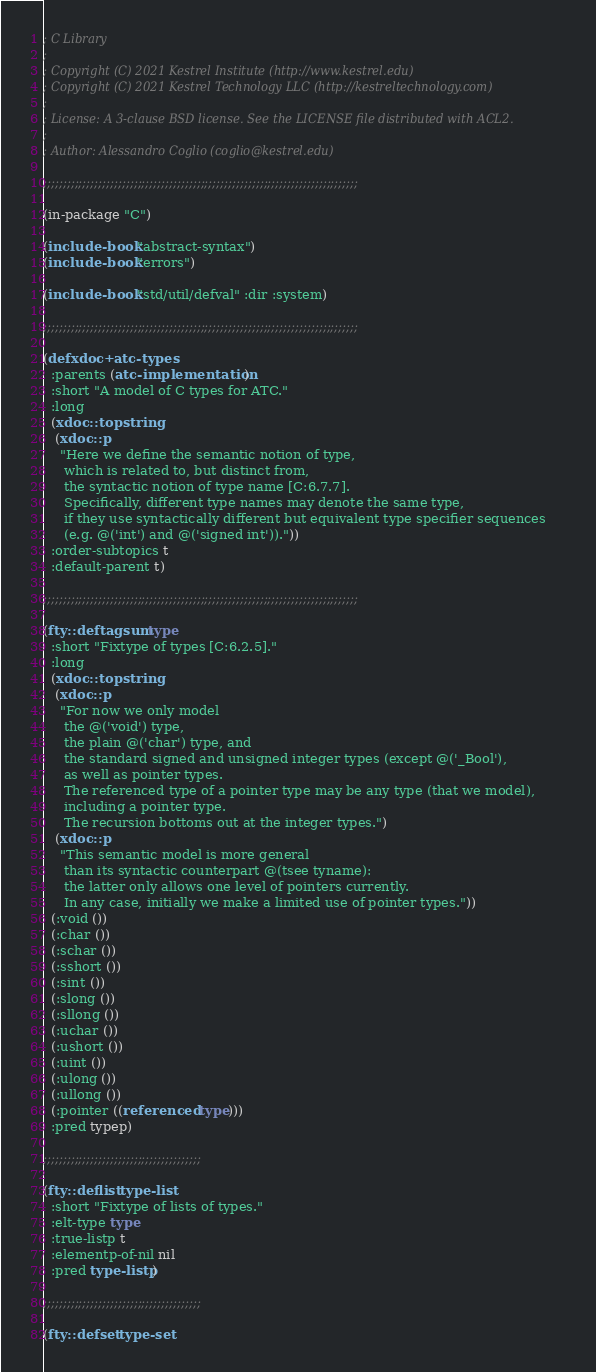Convert code to text. <code><loc_0><loc_0><loc_500><loc_500><_Lisp_>; C Library
;
; Copyright (C) 2021 Kestrel Institute (http://www.kestrel.edu)
; Copyright (C) 2021 Kestrel Technology LLC (http://kestreltechnology.com)
;
; License: A 3-clause BSD license. See the LICENSE file distributed with ACL2.
;
; Author: Alessandro Coglio (coglio@kestrel.edu)

;;;;;;;;;;;;;;;;;;;;;;;;;;;;;;;;;;;;;;;;;;;;;;;;;;;;;;;;;;;;;;;;;;;;;;;;;;;;;;;;

(in-package "C")

(include-book "abstract-syntax")
(include-book "errors")

(include-book "std/util/defval" :dir :system)

;;;;;;;;;;;;;;;;;;;;;;;;;;;;;;;;;;;;;;;;;;;;;;;;;;;;;;;;;;;;;;;;;;;;;;;;;;;;;;;;

(defxdoc+ atc-types
  :parents (atc-implementation)
  :short "A model of C types for ATC."
  :long
  (xdoc::topstring
   (xdoc::p
    "Here we define the semantic notion of type,
     which is related to, but distinct from,
     the syntactic notion of type name [C:6.7.7].
     Specifically, different type names may denote the same type,
     if they use syntactically different but equivalent type specifier sequences
     (e.g. @('int') and @('signed int'))."))
  :order-subtopics t
  :default-parent t)

;;;;;;;;;;;;;;;;;;;;;;;;;;;;;;;;;;;;;;;;;;;;;;;;;;;;;;;;;;;;;;;;;;;;;;;;;;;;;;;;

(fty::deftagsum type
  :short "Fixtype of types [C:6.2.5]."
  :long
  (xdoc::topstring
   (xdoc::p
    "For now we only model
     the @('void') type,
     the plain @('char') type, and
     the standard signed and unsigned integer types (except @('_Bool'),
     as well as pointer types.
     The referenced type of a pointer type may be any type (that we model),
     including a pointer type.
     The recursion bottoms out at the integer types.")
   (xdoc::p
    "This semantic model is more general
     than its syntactic counterpart @(tsee tyname):
     the latter only allows one level of pointers currently.
     In any case, initially we make a limited use of pointer types."))
  (:void ())
  (:char ())
  (:schar ())
  (:sshort ())
  (:sint ())
  (:slong ())
  (:sllong ())
  (:uchar ())
  (:ushort ())
  (:uint ())
  (:ulong ())
  (:ullong ())
  (:pointer ((referenced type)))
  :pred typep)

;;;;;;;;;;;;;;;;;;;;;;;;;;;;;;;;;;;;;;;;

(fty::deflist type-list
  :short "Fixtype of lists of types."
  :elt-type type
  :true-listp t
  :elementp-of-nil nil
  :pred type-listp)

;;;;;;;;;;;;;;;;;;;;;;;;;;;;;;;;;;;;;;;;

(fty::defset type-set</code> 